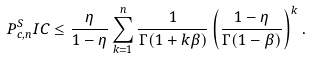Convert formula to latex. <formula><loc_0><loc_0><loc_500><loc_500>P _ { c , n } ^ { S } I C \leq \frac { \eta } { 1 - \eta } \sum _ { k = 1 } ^ { n } \frac { 1 } { \Gamma ( 1 + k \beta ) } \left ( \frac { 1 - \eta } { \Gamma ( 1 - \beta ) } \right ) ^ { k } .</formula> 